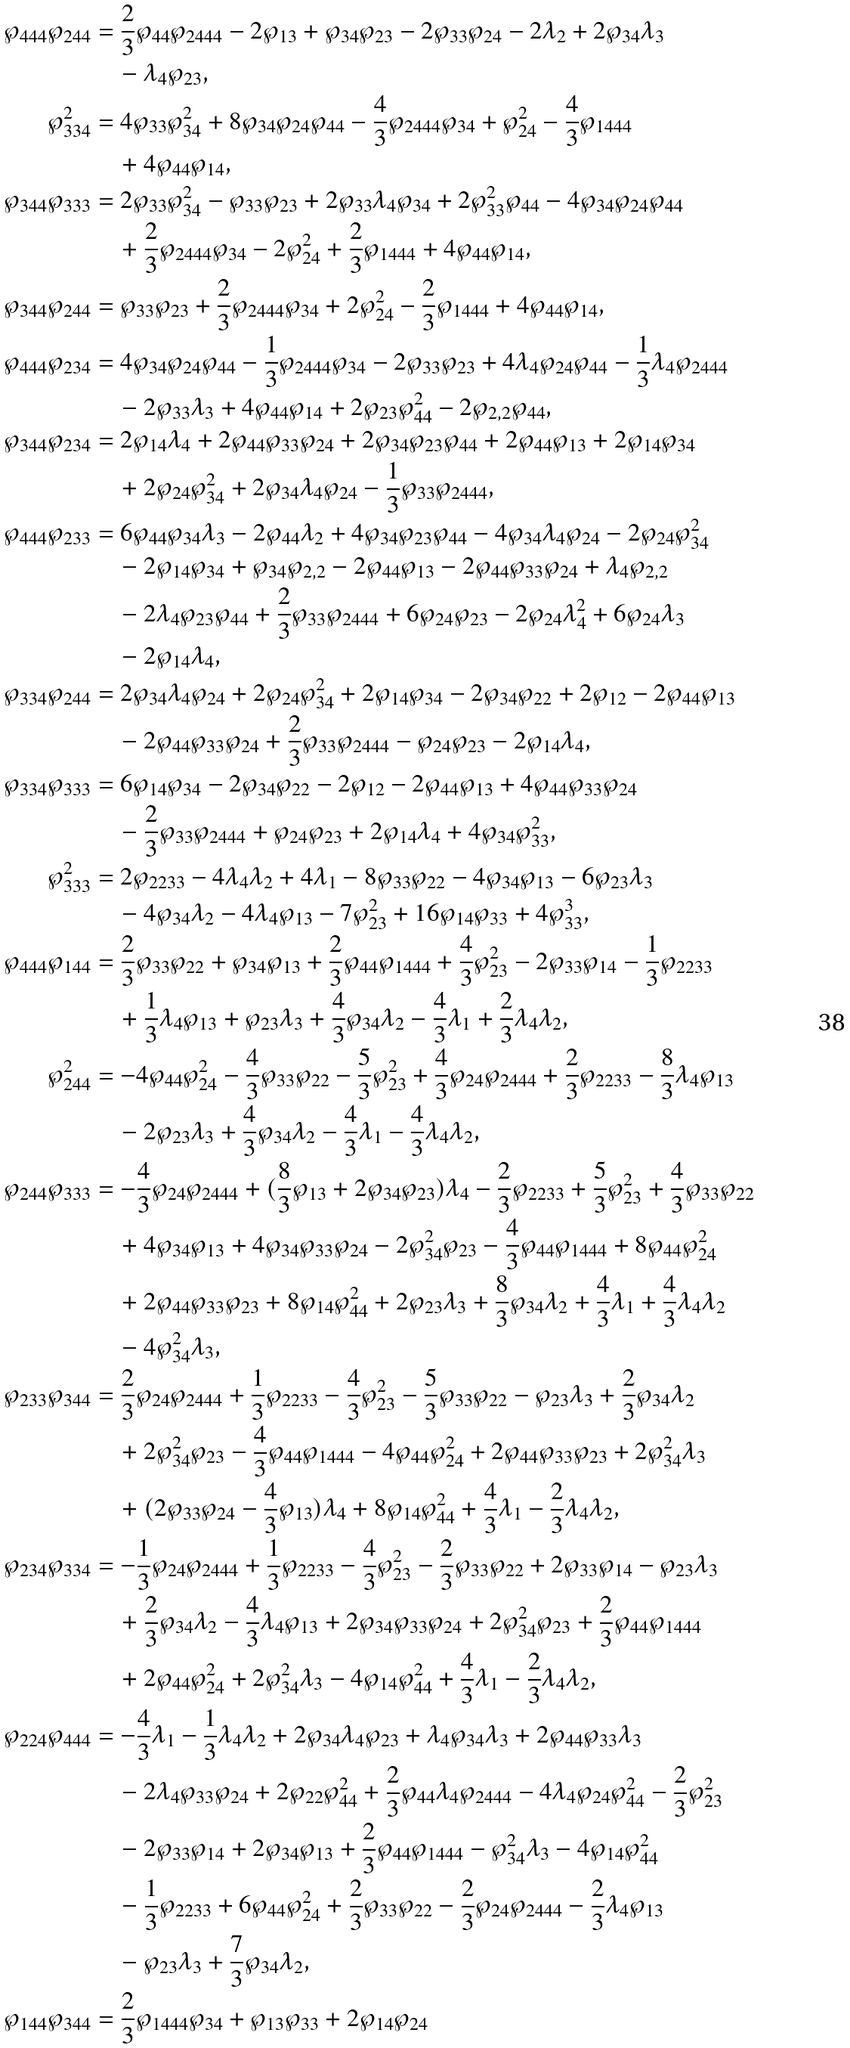Convert formula to latex. <formula><loc_0><loc_0><loc_500><loc_500>\wp _ { 4 4 4 } \wp _ { 2 4 4 } & = \frac { 2 } { 3 } \wp _ { 4 4 } \wp _ { 2 4 4 4 } - 2 \wp _ { 1 3 } + \wp _ { 3 4 } \wp _ { 2 3 } - 2 \wp _ { 3 3 } \wp _ { 2 4 } - 2 \lambda _ { 2 } + 2 \wp _ { 3 4 } \lambda _ { 3 } \\ & \quad - \lambda _ { 4 } \wp _ { 2 3 } , \\ \wp _ { 3 3 4 } ^ { 2 } & = 4 \wp _ { 3 3 } \wp _ { 3 4 } ^ { 2 } + 8 \wp _ { 3 4 } \wp _ { 2 4 } \wp _ { 4 4 } - \frac { 4 } { 3 } \wp _ { 2 4 4 4 } \wp _ { 3 4 } + \wp _ { 2 4 } ^ { 2 } - \frac { 4 } { 3 } \wp _ { 1 4 4 4 } \\ & \quad + 4 \wp _ { 4 4 } \wp _ { 1 4 } , \\ \wp _ { 3 4 4 } \wp _ { 3 3 3 } & = 2 \wp _ { 3 3 } \wp _ { 3 4 } ^ { 2 } - \wp _ { 3 3 } \wp _ { 2 3 } + 2 \wp _ { 3 3 } \lambda _ { 4 } \wp _ { 3 4 } + 2 \wp _ { 3 3 } ^ { 2 } \wp _ { 4 4 } - 4 \wp _ { 3 4 } \wp _ { 2 4 } \wp _ { 4 4 } \\ & \quad + \frac { 2 } { 3 } \wp _ { 2 4 4 4 } \wp _ { 3 4 } - 2 \wp _ { 2 4 } ^ { 2 } + \frac { 2 } { 3 } \wp _ { 1 4 4 4 } + 4 \wp _ { 4 4 } \wp _ { 1 4 } , \\ \wp _ { 3 4 4 } \wp _ { 2 4 4 } & = \wp _ { 3 3 } \wp _ { 2 3 } + \frac { 2 } { 3 } \wp _ { 2 4 4 4 } \wp _ { 3 4 } + 2 \wp _ { 2 4 } ^ { 2 } - \frac { 2 } { 3 } \wp _ { 1 4 4 4 } + 4 \wp _ { 4 4 } \wp _ { 1 4 } , \\ \wp _ { 4 4 4 } \wp _ { 2 3 4 } & = 4 \wp _ { 3 4 } \wp _ { 2 4 } \wp _ { 4 4 } - \frac { 1 } { 3 } \wp _ { 2 4 4 4 } \wp _ { 3 4 } - 2 \wp _ { 3 3 } \wp _ { 2 3 } + 4 \lambda _ { 4 } \wp _ { 2 4 } \wp _ { 4 4 } - \frac { 1 } { 3 } \lambda _ { 4 } \wp _ { 2 4 4 4 } \\ & \quad - 2 \wp _ { 3 3 } \lambda _ { 3 } + 4 \wp _ { 4 4 } \wp _ { 1 4 } + 2 \wp _ { 2 3 } \wp _ { 4 4 } ^ { 2 } - 2 \wp _ { 2 , 2 } \wp _ { 4 4 } , \\ \wp _ { 3 4 4 } \wp _ { 2 3 4 } & = 2 \wp _ { 1 4 } \lambda _ { 4 } + 2 \wp _ { 4 4 } \wp _ { 3 3 } \wp _ { 2 4 } + 2 \wp _ { 3 4 } \wp _ { 2 3 } \wp _ { 4 4 } + 2 \wp _ { 4 4 } \wp _ { 1 3 } + 2 \wp _ { 1 4 } \wp _ { 3 4 } \\ & \quad + 2 \wp _ { 2 4 } \wp _ { 3 4 } ^ { 2 } + 2 \wp _ { 3 4 } \lambda _ { 4 } \wp _ { 2 4 } - \frac { 1 } { 3 } \wp _ { 3 3 } \wp _ { 2 4 4 4 } , \\ \wp _ { 4 4 4 } \wp _ { 2 3 3 } & = 6 \wp _ { 4 4 } \wp _ { 3 4 } \lambda _ { 3 } - 2 \wp _ { 4 4 } \lambda _ { 2 } + 4 \wp _ { 3 4 } \wp _ { 2 3 } \wp _ { 4 4 } - 4 \wp _ { 3 4 } \lambda _ { 4 } \wp _ { 2 4 } - 2 \wp _ { 2 4 } \wp _ { 3 4 } ^ { 2 } \\ & \quad - 2 \wp _ { 1 4 } \wp _ { 3 4 } + \wp _ { 3 4 } \wp _ { 2 , 2 } - 2 \wp _ { 4 4 } \wp _ { 1 3 } - 2 \wp _ { 4 4 } \wp _ { 3 3 } \wp _ { 2 4 } + \lambda _ { 4 } \wp _ { 2 , 2 } \\ & \quad - 2 \lambda _ { 4 } \wp _ { 2 3 } \wp _ { 4 4 } + \frac { 2 } { 3 } \wp _ { 3 3 } \wp _ { 2 4 4 4 } + 6 \wp _ { 2 4 } \wp _ { 2 3 } - 2 \wp _ { 2 4 } \lambda _ { 4 } ^ { 2 } + 6 \wp _ { 2 4 } \lambda _ { 3 } \\ & \quad - 2 \wp _ { 1 4 } \lambda _ { 4 } , \\ \wp _ { 3 3 4 } \wp _ { 2 4 4 } & = 2 \wp _ { 3 4 } \lambda _ { 4 } \wp _ { 2 4 } + 2 \wp _ { 2 4 } \wp _ { 3 4 } ^ { 2 } + 2 \wp _ { 1 4 } \wp _ { 3 4 } - 2 \wp _ { 3 4 } \wp _ { 2 2 } + 2 \wp _ { 1 2 } - 2 \wp _ { 4 4 } \wp _ { 1 3 } \\ & \quad - 2 \wp _ { 4 4 } \wp _ { 3 3 } \wp _ { 2 4 } + \frac { 2 } { 3 } \wp _ { 3 3 } \wp _ { 2 4 4 4 } - \wp _ { 2 4 } \wp _ { 2 3 } - 2 \wp _ { 1 4 } \lambda _ { 4 } , \\ \wp _ { 3 3 4 } \wp _ { 3 3 3 } & = 6 \wp _ { 1 4 } \wp _ { 3 4 } - 2 \wp _ { 3 4 } \wp _ { 2 2 } - 2 \wp _ { 1 2 } - 2 \wp _ { 4 4 } \wp _ { 1 3 } + 4 \wp _ { 4 4 } \wp _ { 3 3 } \wp _ { 2 4 } \\ & \quad - \frac { 2 } { 3 } \wp _ { 3 3 } \wp _ { 2 4 4 4 } + \wp _ { 2 4 } \wp _ { 2 3 } + 2 \wp _ { 1 4 } \lambda _ { 4 } + 4 \wp _ { 3 4 } \wp _ { 3 3 } ^ { 2 } , \\ \wp _ { 3 3 3 } ^ { 2 } & = 2 \wp _ { 2 2 3 3 } - 4 \lambda _ { 4 } \lambda _ { 2 } + 4 \lambda _ { 1 } - 8 \wp _ { 3 3 } \wp _ { 2 2 } - 4 \wp _ { 3 4 } \wp _ { 1 3 } - 6 \wp _ { 2 3 } \lambda _ { 3 } \\ & \quad - 4 \wp _ { 3 4 } \lambda _ { 2 } - 4 \lambda _ { 4 } \wp _ { 1 3 } - 7 \wp _ { 2 3 } ^ { 2 } + 1 6 \wp _ { 1 4 } \wp _ { 3 3 } + 4 \wp _ { 3 3 } ^ { 3 } , \\ \wp _ { 4 4 4 } \wp _ { 1 4 4 } & = \frac { 2 } { 3 } \wp _ { 3 3 } \wp _ { 2 2 } + \wp _ { 3 4 } \wp _ { 1 3 } + \frac { 2 } { 3 } \wp _ { 4 4 } \wp _ { 1 4 4 4 } + \frac { 4 } { 3 } \wp _ { 2 3 } ^ { 2 } - 2 \wp _ { 3 3 } \wp _ { 1 4 } - \frac { 1 } { 3 } \wp _ { 2 2 3 3 } \\ & \quad + \frac { 1 } { 3 } \lambda _ { 4 } \wp _ { 1 3 } + \wp _ { 2 3 } \lambda _ { 3 } + \frac { 4 } { 3 } \wp _ { 3 4 } \lambda _ { 2 } - \frac { 4 } { 3 } \lambda _ { 1 } + \frac { 2 } { 3 } \lambda _ { 4 } \lambda _ { 2 } , \\ \wp _ { 2 4 4 } ^ { 2 } & = - 4 \wp _ { 4 4 } \wp _ { 2 4 } ^ { 2 } - \frac { 4 } { 3 } \wp _ { 3 3 } \wp _ { 2 2 } - \frac { 5 } { 3 } \wp _ { 2 3 } ^ { 2 } + \frac { 4 } { 3 } \wp _ { 2 4 } \wp _ { 2 4 4 4 } + \frac { 2 } { 3 } \wp _ { 2 2 3 3 } - \frac { 8 } { 3 } \lambda _ { 4 } \wp _ { 1 3 } \\ & \quad - 2 \wp _ { 2 3 } \lambda _ { 3 } + \frac { 4 } { 3 } \wp _ { 3 4 } \lambda _ { 2 } - \frac { 4 } { 3 } \lambda _ { 1 } - \frac { 4 } { 3 } \lambda _ { 4 } \lambda _ { 2 } , \\ \wp _ { 2 4 4 } \wp _ { 3 3 3 } & = - \frac { 4 } { 3 } \wp _ { 2 4 } \wp _ { 2 4 4 4 } + ( \frac { 8 } { 3 } \wp _ { 1 3 } + 2 \wp _ { 3 4 } \wp _ { 2 3 } ) \lambda _ { 4 } - \frac { 2 } { 3 } \wp _ { 2 2 3 3 } + \frac { 5 } { 3 } \wp _ { 2 3 } ^ { 2 } + \frac { 4 } { 3 } \wp _ { 3 3 } \wp _ { 2 2 } \\ & \quad + 4 \wp _ { 3 4 } \wp _ { 1 3 } + 4 \wp _ { 3 4 } \wp _ { 3 3 } \wp _ { 2 4 } - 2 \wp _ { 3 4 } ^ { 2 } \wp _ { 2 3 } - \frac { 4 } { 3 } \wp _ { 4 4 } \wp _ { 1 4 4 4 } + 8 \wp _ { 4 4 } \wp _ { 2 4 } ^ { 2 } \\ & \quad + 2 \wp _ { 4 4 } \wp _ { 3 3 } \wp _ { 2 3 } + 8 \wp _ { 1 4 } \wp _ { 4 4 } ^ { 2 } + 2 \wp _ { 2 3 } \lambda _ { 3 } + \frac { 8 } { 3 } \wp _ { 3 4 } \lambda _ { 2 } + \frac { 4 } { 3 } \lambda _ { 1 } + \frac { 4 } { 3 } \lambda _ { 4 } \lambda _ { 2 } \\ & \quad - 4 \wp _ { 3 4 } ^ { 2 } \lambda _ { 3 } , \\ \wp _ { 2 3 3 } \wp _ { 3 4 4 } & = \frac { 2 } { 3 } \wp _ { 2 4 } \wp _ { 2 4 4 4 } + \frac { 1 } { 3 } \wp _ { 2 2 3 3 } - \frac { 4 } { 3 } \wp _ { 2 3 } ^ { 2 } - \frac { 5 } { 3 } \wp _ { 3 3 } \wp _ { 2 2 } - \wp _ { 2 3 } \lambda _ { 3 } + \frac { 2 } { 3 } \wp _ { 3 4 } \lambda _ { 2 } \\ & \quad + 2 \wp _ { 3 4 } ^ { 2 } \wp _ { 2 3 } - \frac { 4 } { 3 } \wp _ { 4 4 } \wp _ { 1 4 4 4 } - 4 \wp _ { 4 4 } \wp _ { 2 4 } ^ { 2 } + 2 \wp _ { 4 4 } \wp _ { 3 3 } \wp _ { 2 3 } + 2 \wp _ { 3 4 } ^ { 2 } \lambda _ { 3 } \\ & \quad + ( 2 \wp _ { 3 3 } \wp _ { 2 4 } - \frac { 4 } { 3 } \wp _ { 1 3 } ) \lambda _ { 4 } + 8 \wp _ { 1 4 } \wp _ { 4 4 } ^ { 2 } + \frac { 4 } { 3 } \lambda _ { 1 } - \frac { 2 } { 3 } \lambda _ { 4 } \lambda _ { 2 } , \\ \wp _ { 2 3 4 } \wp _ { 3 3 4 } & = - \frac { 1 } { 3 } \wp _ { 2 4 } \wp _ { 2 4 4 4 } + \frac { 1 } { 3 } \wp _ { 2 2 3 3 } - \frac { 4 } { 3 } \wp _ { 2 3 } ^ { 2 } - \frac { 2 } { 3 } \wp _ { 3 3 } \wp _ { 2 2 } + 2 \wp _ { 3 3 } \wp _ { 1 4 } - \wp _ { 2 3 } \lambda _ { 3 } \\ & \quad + \frac { 2 } { 3 } \wp _ { 3 4 } \lambda _ { 2 } - \frac { 4 } { 3 } \lambda _ { 4 } \wp _ { 1 3 } + 2 \wp _ { 3 4 } \wp _ { 3 3 } \wp _ { 2 4 } + 2 \wp _ { 3 4 } ^ { 2 } \wp _ { 2 3 } + \frac { 2 } { 3 } \wp _ { 4 4 } \wp _ { 1 4 4 4 } \\ & \quad + 2 \wp _ { 4 4 } \wp _ { 2 4 } ^ { 2 } + 2 \wp _ { 3 4 } ^ { 2 } \lambda _ { 3 } - 4 \wp _ { 1 4 } \wp _ { 4 4 } ^ { 2 } + \frac { 4 } { 3 } \lambda _ { 1 } - \frac { 2 } { 3 } \lambda _ { 4 } \lambda _ { 2 } , \\ \wp _ { 2 2 4 } \wp _ { 4 4 4 } & = - \frac { 4 } { 3 } \lambda _ { 1 } - \frac { 1 } { 3 } \lambda _ { 4 } \lambda _ { 2 } + 2 \wp _ { 3 4 } \lambda _ { 4 } \wp _ { 2 3 } + \lambda _ { 4 } \wp _ { 3 4 } \lambda _ { 3 } + 2 \wp _ { 4 4 } \wp _ { 3 3 } \lambda _ { 3 } \\ & \quad - 2 \lambda _ { 4 } \wp _ { 3 3 } \wp _ { 2 4 } + 2 \wp _ { 2 2 } \wp _ { 4 4 } ^ { 2 } + \frac { 2 } { 3 } \wp _ { 4 4 } \lambda _ { 4 } \wp _ { 2 4 4 4 } - 4 \lambda _ { 4 } \wp _ { 2 4 } \wp _ { 4 4 } ^ { 2 } - \frac { 2 } { 3 } \wp _ { 2 3 } ^ { 2 } \\ & \quad - 2 \wp _ { 3 3 } \wp _ { 1 4 } + 2 \wp _ { 3 4 } \wp _ { 1 3 } + \frac { 2 } { 3 } \wp _ { 4 4 } \wp _ { 1 4 4 4 } - \wp _ { 3 4 } ^ { 2 } \lambda _ { 3 } - 4 \wp _ { 1 4 } \wp _ { 4 4 } ^ { 2 } \\ & \quad - \frac { 1 } { 3 } \wp _ { 2 2 3 3 } + 6 \wp _ { 4 4 } \wp _ { 2 4 } ^ { 2 } + \frac { 2 } { 3 } \wp _ { 3 3 } \wp _ { 2 2 } - \frac { 2 } { 3 } \wp _ { 2 4 } \wp _ { 2 4 4 4 } - \frac { 2 } { 3 } \lambda _ { 4 } \wp _ { 1 3 } \\ & \quad - \wp _ { 2 3 } \lambda _ { 3 } + \frac { 7 } { 3 } \wp _ { 3 4 } \lambda _ { 2 } , \\ \wp _ { 1 4 4 } \wp _ { 3 4 4 } & = \frac { 2 } { 3 } \wp _ { 1 4 4 4 } \wp _ { 3 4 } + \wp _ { 1 3 } \wp _ { 3 3 } + 2 \wp _ { 1 4 } \wp _ { 2 4 }</formula> 